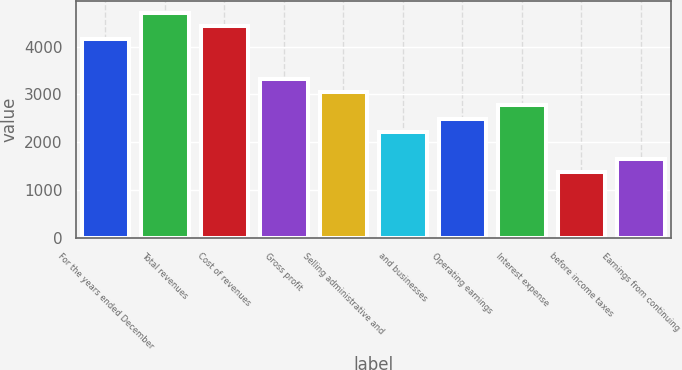<chart> <loc_0><loc_0><loc_500><loc_500><bar_chart><fcel>For the years ended December<fcel>Total revenues<fcel>Cost of revenues<fcel>Gross profit<fcel>Selling administrative and<fcel>and businesses<fcel>Operating earnings<fcel>Interest expense<fcel>before income taxes<fcel>Earnings from continuing<nl><fcel>4156.08<fcel>4710.22<fcel>4433.15<fcel>3324.87<fcel>3047.8<fcel>2216.59<fcel>2493.66<fcel>2770.73<fcel>1385.38<fcel>1662.45<nl></chart> 